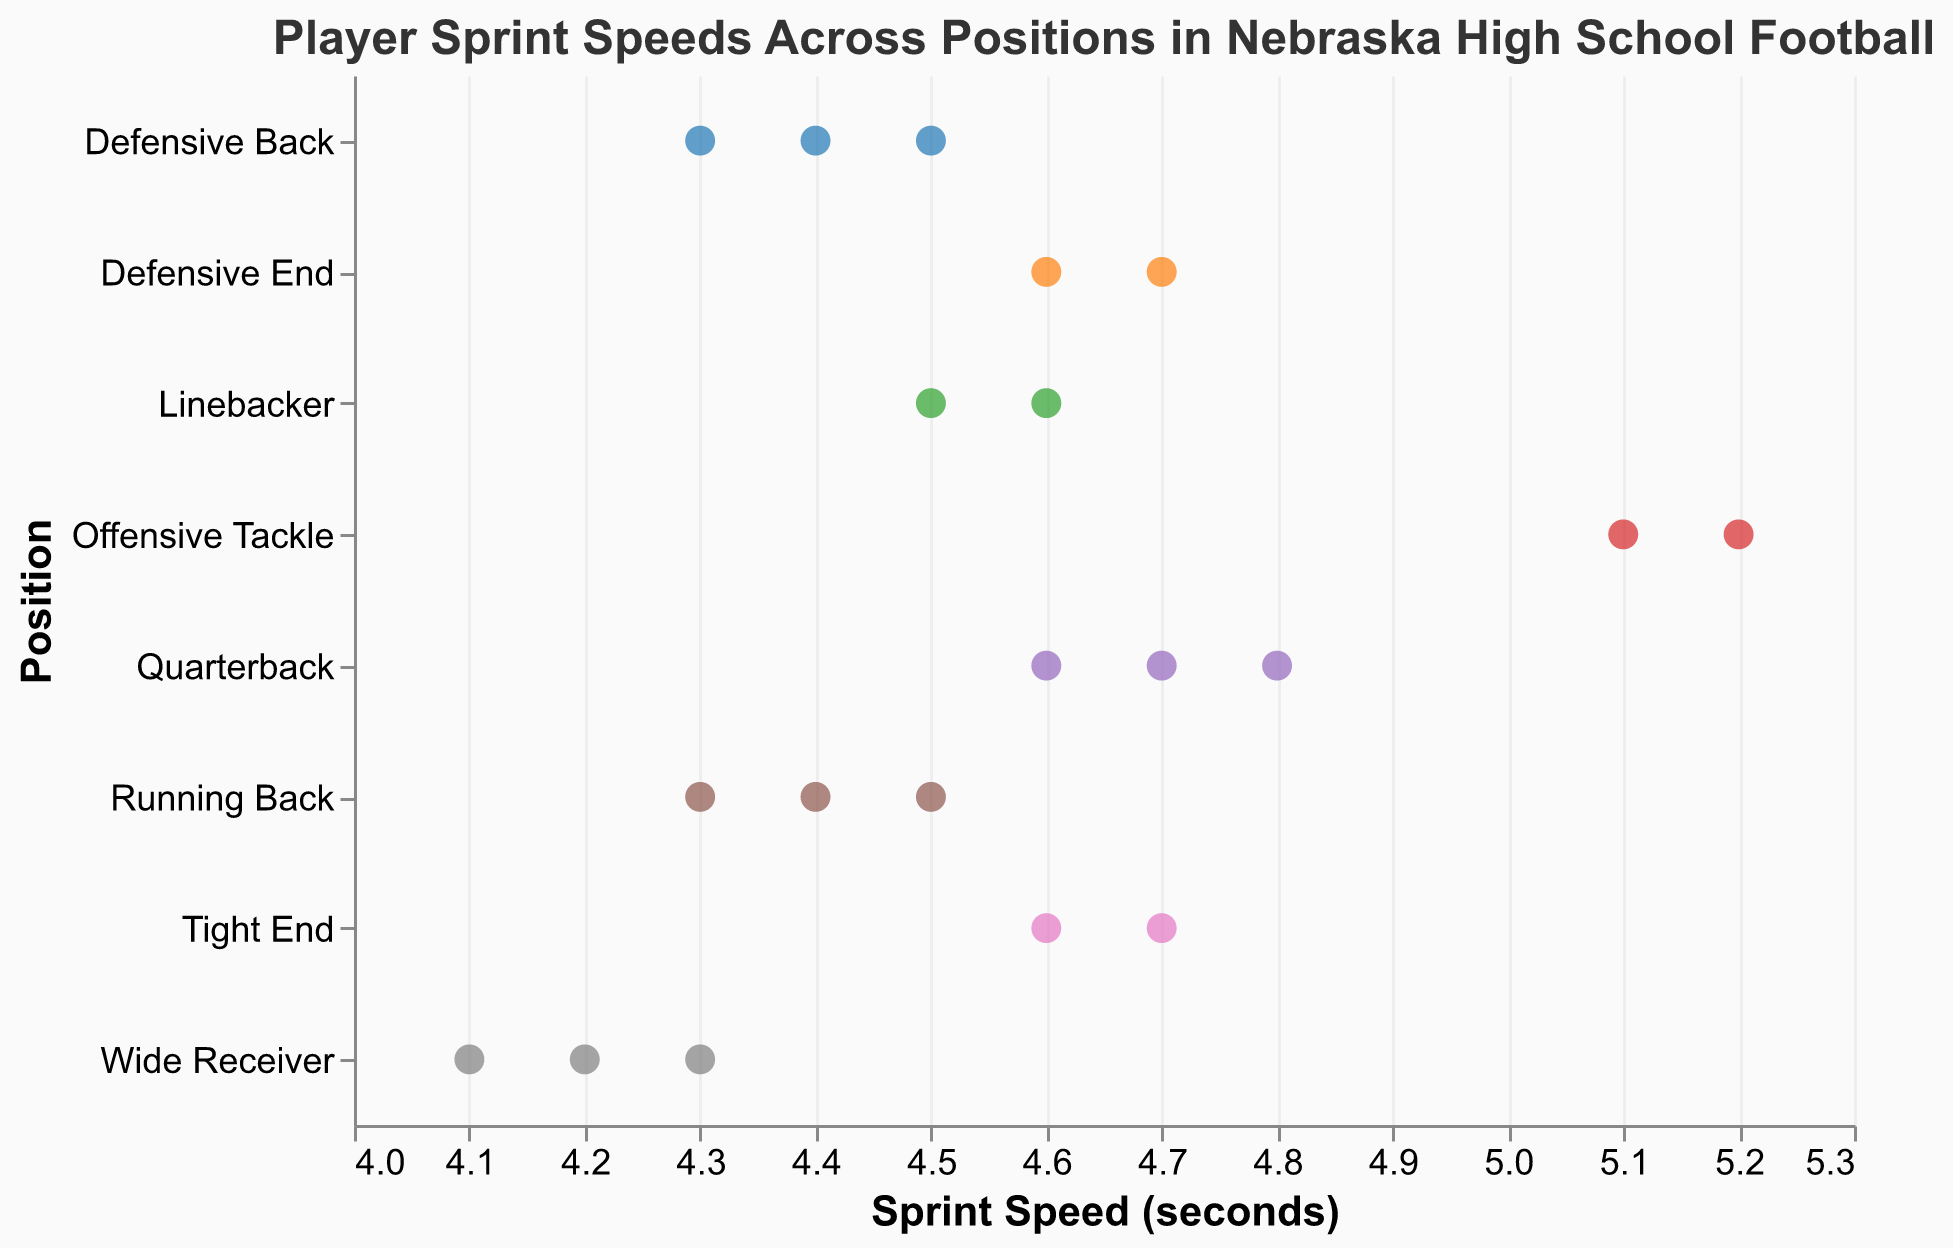What's the title of the plot? The title of the plot is typically displayed at the top and summarizes the content of the figure.
Answer: Player Sprint Speeds Across Positions in Nebraska High School Football Which position has the highest sprint speed? To find the position with the highest sprint speed, look at the x-axis which represents sprint speed in seconds, and find the smallest value. The smallest value corresponds to the highest speed.
Answer: Wide Receiver What is the average sprint speed for Quarterbacks? There are three quarterbacks with sprint speeds of 4.7, 4.8, and 4.6. Calculate the average by summing these values and dividing by 3. Average = (4.7 + 4.8 + 4.6) / 3 = 4.7
Answer: 4.7 How does the sprint speed of Offensive Tackles compare to that of Defensive Backs? To compare, observe the x-axis values for both positions. Offensive Tackles have sprint speeds of 5.1 and 5.2, while Defensive Backs have 4.3, 4.4, and 4.5. Offensive Tackles have higher sprint speeds (slower) than Defensive Backs.
Answer: Offensive Tackles are slower Which position shows the greatest range of sprint speeds? The range of sprint speed can be determined by identifying the spread of values on the x-axis for each position. Wide Receivers have speeds between 4.1 and 4.3, a range of 0.2 seconds.
Answer: Tight Ends Who is the fastest player and what position do they play? Identify the player with the lowest sprint speed value on the x-axis. Trey Palmer has the lowest sprint speed of 4.1, indicating he is the fastest. He plays Wide Receiver.
Answer: Trey Palmer, Wide Receiver What's the sprint speed of the slowest player? The slowest player corresponds to the highest value on the x-axis. The highest sprint speed is 5.2, observed for Offensive Tackle Bryce Benhart.
Answer: 5.2 Are there any positions where all players have the same sprint speed? Scan the figure for positions where all points are aligned vertically at the same x-axis value. No such position is observed as each position has a range of sprint speeds.
Answer: No What is the median sprint speed for Running Backs? There are three Running Backs with sprint speeds of 4.3, 4.4, and 4.5. The median is the middle value in an ordered list. Ordered speeds: 4.3, 4.4, 4.5, so the median is 4.4.
Answer: 4.4 